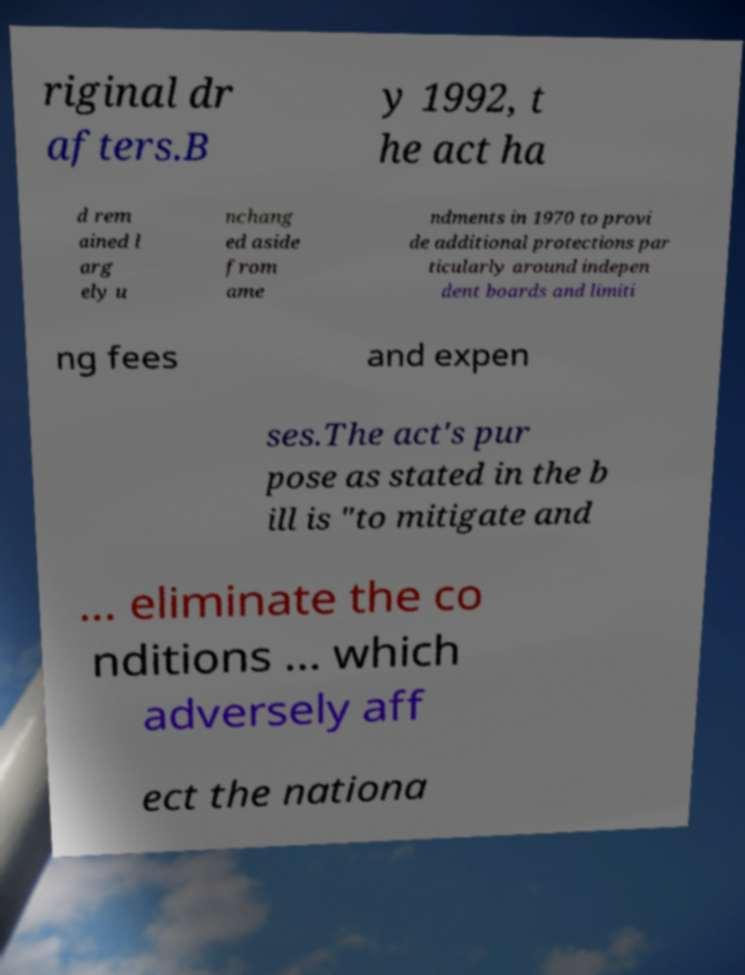Could you extract and type out the text from this image? riginal dr afters.B y 1992, t he act ha d rem ained l arg ely u nchang ed aside from ame ndments in 1970 to provi de additional protections par ticularly around indepen dent boards and limiti ng fees and expen ses.The act's pur pose as stated in the b ill is "to mitigate and ... eliminate the co nditions ... which adversely aff ect the nationa 